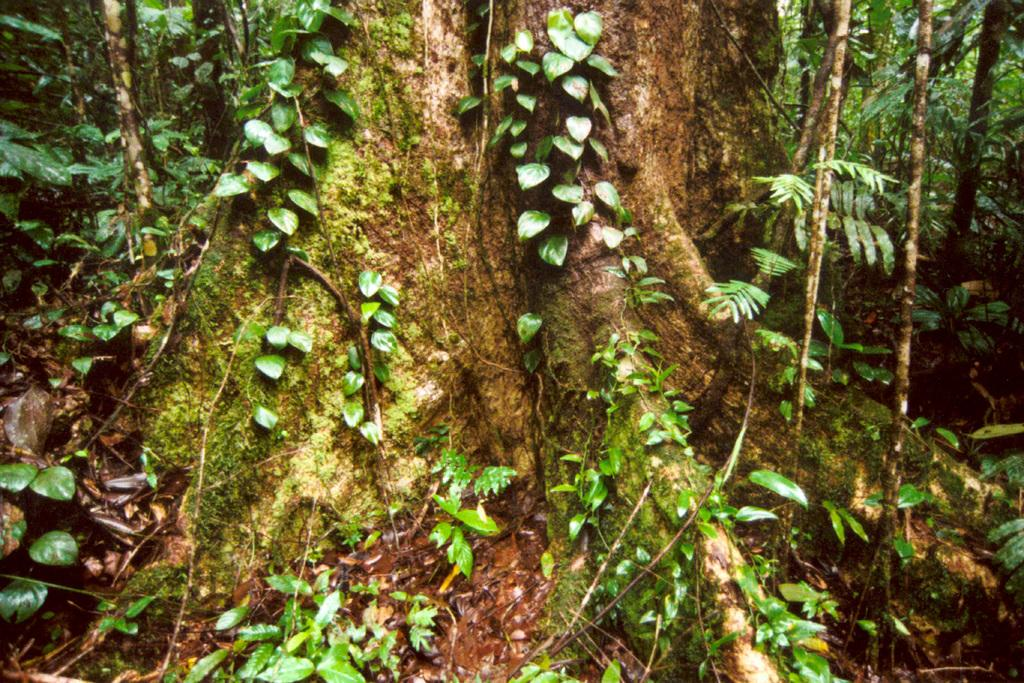What type of plant material can be seen in the image? There are leaves, branches, and roots in the image. What other type of vegetation is present in the image? There is grass in the image. What type of tool is used to tighten or loosen bolts in the image? There is no tool present in the image, let alone a wrench for tightening or loosening bolts. 